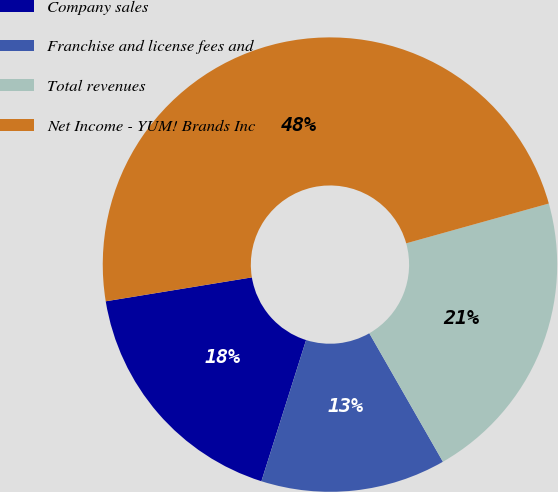Convert chart to OTSL. <chart><loc_0><loc_0><loc_500><loc_500><pie_chart><fcel>Company sales<fcel>Franchise and license fees and<fcel>Total revenues<fcel>Net Income - YUM! Brands Inc<nl><fcel>17.54%<fcel>13.16%<fcel>21.05%<fcel>48.25%<nl></chart> 